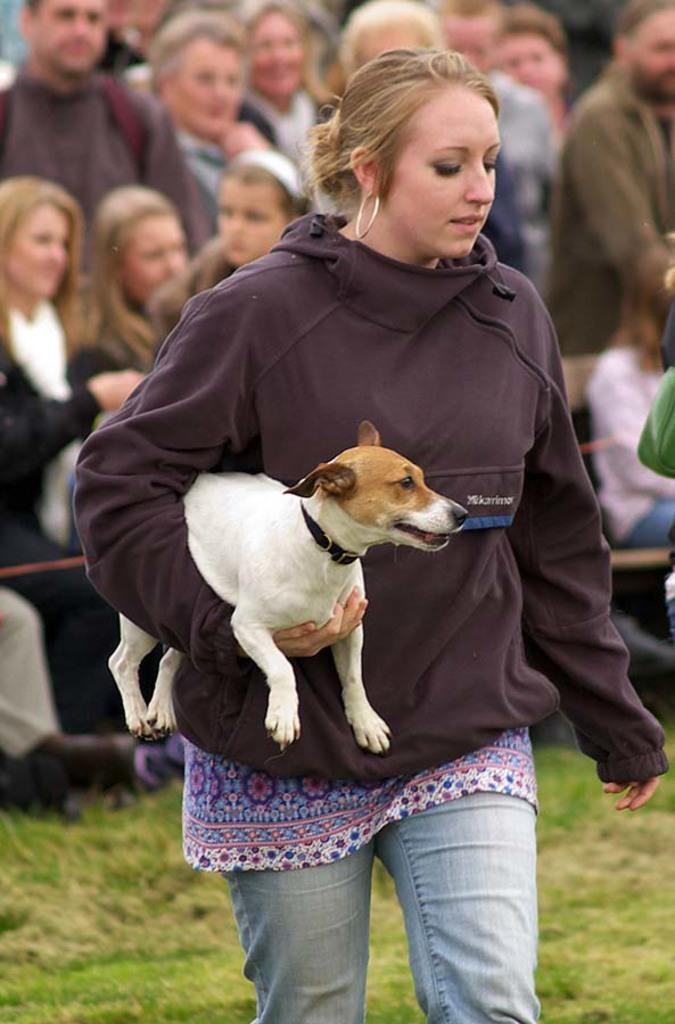Can you describe this image briefly? In this picture a lady is holding with one of her hands and in the background we observe many people are standing and few of them are sitting. The picture is clicked outside. The floor is filled with grass. 